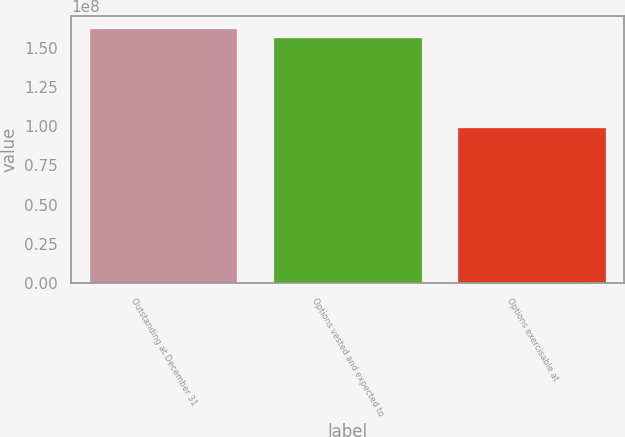<chart> <loc_0><loc_0><loc_500><loc_500><bar_chart><fcel>Outstanding at December 31<fcel>Options vested and expected to<fcel>Options exercisable at<nl><fcel>1.62073e+08<fcel>1.56252e+08<fcel>9.8859e+07<nl></chart> 